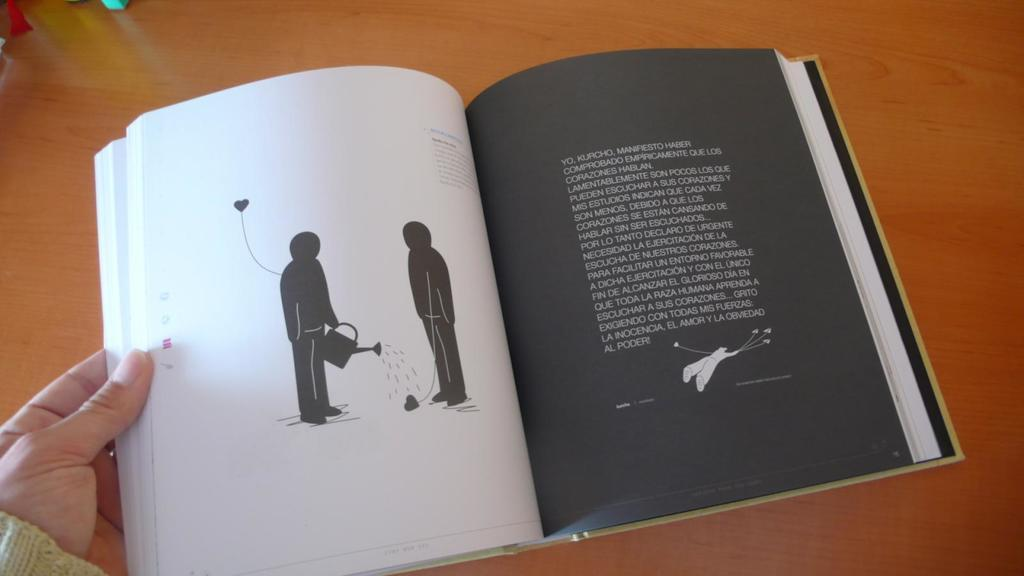What object is in the image that is related to reading? There is a book in the image. Where is the book located in the image? The book is on a surface. Who is holding the book in the image? A person's hand is holding the book. What can be found on the book's cover or pages? There is writing and an image on the book. What type of pleasure can be seen in the image? There is no indication of pleasure in the image; it features a book being held by a person. What type of calendar is visible in the image? There is no calendar present in the image. 